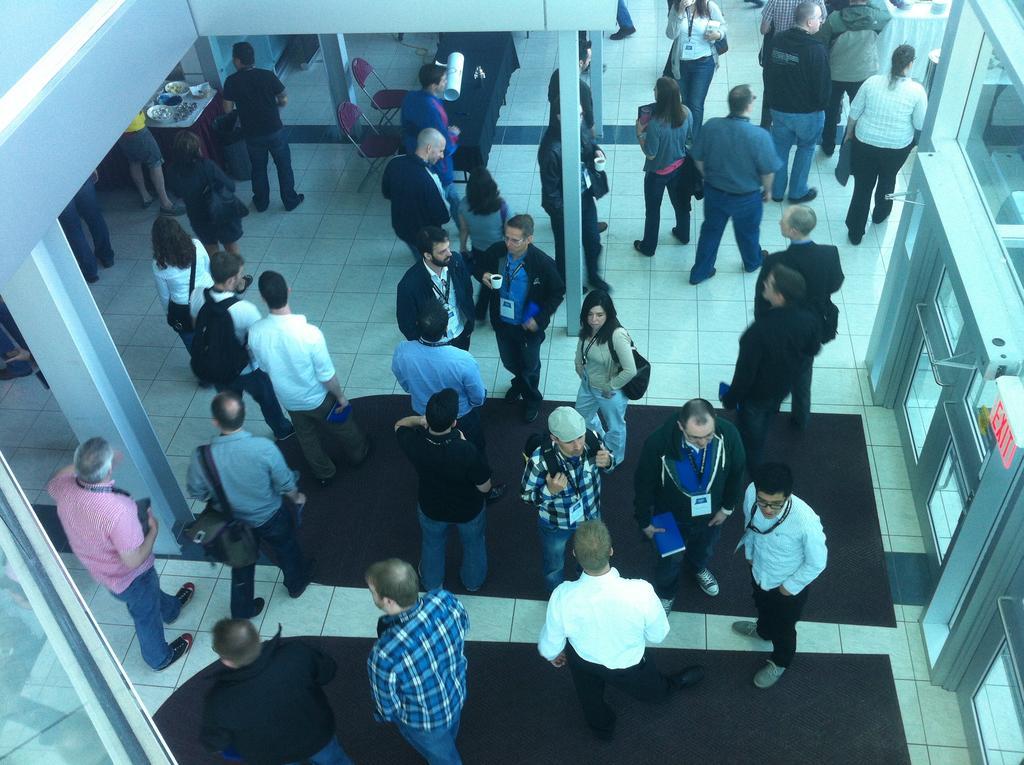Describe this image in one or two sentences. In this picture there are group of people moving around. At the bottom, there is a man wearing a check shirt, behind him, there is another man wearing black shirt. At the bottom, on the floor there are mats. Towards the right, there is a door. On the top, there are pillars. 